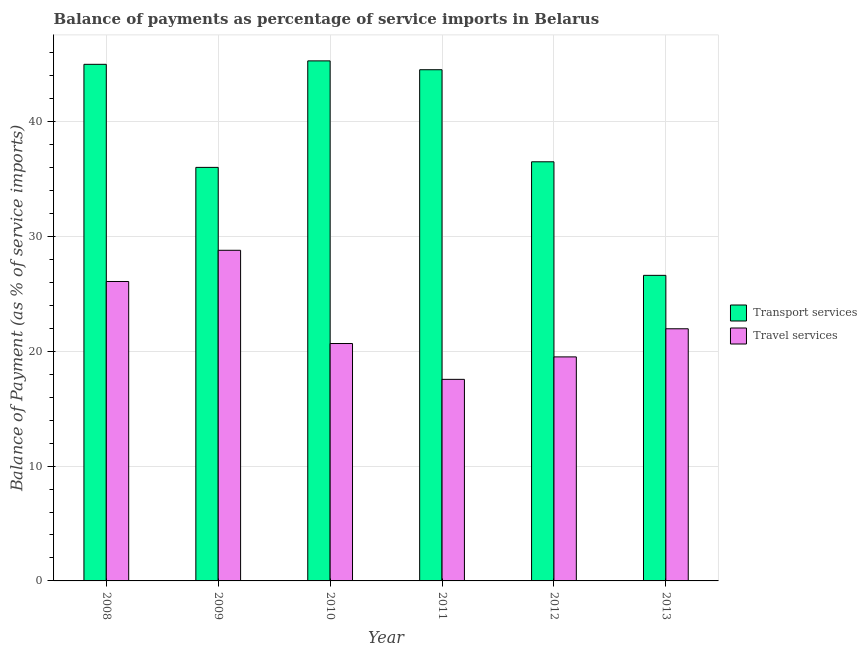How many different coloured bars are there?
Your answer should be compact. 2. Are the number of bars per tick equal to the number of legend labels?
Your answer should be very brief. Yes. Are the number of bars on each tick of the X-axis equal?
Your answer should be very brief. Yes. In how many cases, is the number of bars for a given year not equal to the number of legend labels?
Your answer should be compact. 0. What is the balance of payments of travel services in 2012?
Offer a terse response. 19.5. Across all years, what is the maximum balance of payments of transport services?
Your answer should be compact. 45.28. Across all years, what is the minimum balance of payments of travel services?
Provide a short and direct response. 17.55. What is the total balance of payments of transport services in the graph?
Provide a short and direct response. 233.87. What is the difference between the balance of payments of transport services in 2010 and that in 2012?
Provide a succinct answer. 8.79. What is the difference between the balance of payments of travel services in 2012 and the balance of payments of transport services in 2010?
Provide a short and direct response. -1.16. What is the average balance of payments of transport services per year?
Provide a succinct answer. 38.98. In the year 2008, what is the difference between the balance of payments of travel services and balance of payments of transport services?
Offer a very short reply. 0. In how many years, is the balance of payments of travel services greater than 44 %?
Provide a succinct answer. 0. What is the ratio of the balance of payments of transport services in 2008 to that in 2009?
Make the answer very short. 1.25. Is the balance of payments of travel services in 2010 less than that in 2012?
Provide a short and direct response. No. Is the difference between the balance of payments of transport services in 2009 and 2013 greater than the difference between the balance of payments of travel services in 2009 and 2013?
Keep it short and to the point. No. What is the difference between the highest and the second highest balance of payments of transport services?
Ensure brevity in your answer.  0.3. What is the difference between the highest and the lowest balance of payments of travel services?
Ensure brevity in your answer.  11.24. What does the 1st bar from the left in 2013 represents?
Provide a short and direct response. Transport services. What does the 2nd bar from the right in 2012 represents?
Offer a very short reply. Transport services. How many bars are there?
Provide a short and direct response. 12. Are all the bars in the graph horizontal?
Offer a very short reply. No. What is the difference between two consecutive major ticks on the Y-axis?
Offer a terse response. 10. Are the values on the major ticks of Y-axis written in scientific E-notation?
Provide a succinct answer. No. Where does the legend appear in the graph?
Make the answer very short. Center right. What is the title of the graph?
Provide a short and direct response. Balance of payments as percentage of service imports in Belarus. What is the label or title of the X-axis?
Provide a short and direct response. Year. What is the label or title of the Y-axis?
Your answer should be very brief. Balance of Payment (as % of service imports). What is the Balance of Payment (as % of service imports) in Transport services in 2008?
Give a very brief answer. 44.98. What is the Balance of Payment (as % of service imports) in Travel services in 2008?
Give a very brief answer. 26.07. What is the Balance of Payment (as % of service imports) in Transport services in 2009?
Give a very brief answer. 36.01. What is the Balance of Payment (as % of service imports) in Travel services in 2009?
Provide a succinct answer. 28.79. What is the Balance of Payment (as % of service imports) of Transport services in 2010?
Ensure brevity in your answer.  45.28. What is the Balance of Payment (as % of service imports) in Travel services in 2010?
Provide a short and direct response. 20.67. What is the Balance of Payment (as % of service imports) of Transport services in 2011?
Give a very brief answer. 44.51. What is the Balance of Payment (as % of service imports) of Travel services in 2011?
Your response must be concise. 17.55. What is the Balance of Payment (as % of service imports) in Transport services in 2012?
Offer a very short reply. 36.49. What is the Balance of Payment (as % of service imports) of Travel services in 2012?
Your answer should be very brief. 19.5. What is the Balance of Payment (as % of service imports) in Transport services in 2013?
Ensure brevity in your answer.  26.61. What is the Balance of Payment (as % of service imports) in Travel services in 2013?
Give a very brief answer. 21.95. Across all years, what is the maximum Balance of Payment (as % of service imports) of Transport services?
Give a very brief answer. 45.28. Across all years, what is the maximum Balance of Payment (as % of service imports) of Travel services?
Provide a succinct answer. 28.79. Across all years, what is the minimum Balance of Payment (as % of service imports) in Transport services?
Offer a terse response. 26.61. Across all years, what is the minimum Balance of Payment (as % of service imports) in Travel services?
Your response must be concise. 17.55. What is the total Balance of Payment (as % of service imports) of Transport services in the graph?
Offer a terse response. 233.87. What is the total Balance of Payment (as % of service imports) of Travel services in the graph?
Offer a terse response. 134.53. What is the difference between the Balance of Payment (as % of service imports) of Transport services in 2008 and that in 2009?
Keep it short and to the point. 8.97. What is the difference between the Balance of Payment (as % of service imports) of Travel services in 2008 and that in 2009?
Ensure brevity in your answer.  -2.72. What is the difference between the Balance of Payment (as % of service imports) of Transport services in 2008 and that in 2010?
Ensure brevity in your answer.  -0.3. What is the difference between the Balance of Payment (as % of service imports) of Travel services in 2008 and that in 2010?
Your response must be concise. 5.4. What is the difference between the Balance of Payment (as % of service imports) of Transport services in 2008 and that in 2011?
Keep it short and to the point. 0.47. What is the difference between the Balance of Payment (as % of service imports) in Travel services in 2008 and that in 2011?
Give a very brief answer. 8.52. What is the difference between the Balance of Payment (as % of service imports) of Transport services in 2008 and that in 2012?
Make the answer very short. 8.49. What is the difference between the Balance of Payment (as % of service imports) of Travel services in 2008 and that in 2012?
Offer a terse response. 6.57. What is the difference between the Balance of Payment (as % of service imports) in Transport services in 2008 and that in 2013?
Your answer should be very brief. 18.37. What is the difference between the Balance of Payment (as % of service imports) of Travel services in 2008 and that in 2013?
Your answer should be very brief. 4.12. What is the difference between the Balance of Payment (as % of service imports) in Transport services in 2009 and that in 2010?
Provide a succinct answer. -9.27. What is the difference between the Balance of Payment (as % of service imports) in Travel services in 2009 and that in 2010?
Offer a very short reply. 8.12. What is the difference between the Balance of Payment (as % of service imports) of Transport services in 2009 and that in 2011?
Your response must be concise. -8.5. What is the difference between the Balance of Payment (as % of service imports) in Travel services in 2009 and that in 2011?
Your response must be concise. 11.24. What is the difference between the Balance of Payment (as % of service imports) in Transport services in 2009 and that in 2012?
Offer a terse response. -0.49. What is the difference between the Balance of Payment (as % of service imports) of Travel services in 2009 and that in 2012?
Make the answer very short. 9.28. What is the difference between the Balance of Payment (as % of service imports) of Transport services in 2009 and that in 2013?
Make the answer very short. 9.4. What is the difference between the Balance of Payment (as % of service imports) of Travel services in 2009 and that in 2013?
Offer a very short reply. 6.83. What is the difference between the Balance of Payment (as % of service imports) of Transport services in 2010 and that in 2011?
Your response must be concise. 0.77. What is the difference between the Balance of Payment (as % of service imports) of Travel services in 2010 and that in 2011?
Keep it short and to the point. 3.12. What is the difference between the Balance of Payment (as % of service imports) in Transport services in 2010 and that in 2012?
Offer a very short reply. 8.79. What is the difference between the Balance of Payment (as % of service imports) of Travel services in 2010 and that in 2012?
Offer a very short reply. 1.16. What is the difference between the Balance of Payment (as % of service imports) in Transport services in 2010 and that in 2013?
Keep it short and to the point. 18.67. What is the difference between the Balance of Payment (as % of service imports) of Travel services in 2010 and that in 2013?
Your answer should be compact. -1.28. What is the difference between the Balance of Payment (as % of service imports) in Transport services in 2011 and that in 2012?
Offer a terse response. 8.02. What is the difference between the Balance of Payment (as % of service imports) of Travel services in 2011 and that in 2012?
Make the answer very short. -1.96. What is the difference between the Balance of Payment (as % of service imports) in Transport services in 2011 and that in 2013?
Ensure brevity in your answer.  17.9. What is the difference between the Balance of Payment (as % of service imports) in Travel services in 2011 and that in 2013?
Offer a very short reply. -4.4. What is the difference between the Balance of Payment (as % of service imports) in Transport services in 2012 and that in 2013?
Offer a very short reply. 9.89. What is the difference between the Balance of Payment (as % of service imports) of Travel services in 2012 and that in 2013?
Offer a terse response. -2.45. What is the difference between the Balance of Payment (as % of service imports) in Transport services in 2008 and the Balance of Payment (as % of service imports) in Travel services in 2009?
Offer a terse response. 16.19. What is the difference between the Balance of Payment (as % of service imports) in Transport services in 2008 and the Balance of Payment (as % of service imports) in Travel services in 2010?
Ensure brevity in your answer.  24.31. What is the difference between the Balance of Payment (as % of service imports) of Transport services in 2008 and the Balance of Payment (as % of service imports) of Travel services in 2011?
Provide a succinct answer. 27.43. What is the difference between the Balance of Payment (as % of service imports) of Transport services in 2008 and the Balance of Payment (as % of service imports) of Travel services in 2012?
Your answer should be compact. 25.47. What is the difference between the Balance of Payment (as % of service imports) of Transport services in 2008 and the Balance of Payment (as % of service imports) of Travel services in 2013?
Give a very brief answer. 23.03. What is the difference between the Balance of Payment (as % of service imports) of Transport services in 2009 and the Balance of Payment (as % of service imports) of Travel services in 2010?
Your answer should be very brief. 15.34. What is the difference between the Balance of Payment (as % of service imports) of Transport services in 2009 and the Balance of Payment (as % of service imports) of Travel services in 2011?
Make the answer very short. 18.46. What is the difference between the Balance of Payment (as % of service imports) in Transport services in 2009 and the Balance of Payment (as % of service imports) in Travel services in 2012?
Offer a very short reply. 16.5. What is the difference between the Balance of Payment (as % of service imports) of Transport services in 2009 and the Balance of Payment (as % of service imports) of Travel services in 2013?
Your answer should be compact. 14.05. What is the difference between the Balance of Payment (as % of service imports) of Transport services in 2010 and the Balance of Payment (as % of service imports) of Travel services in 2011?
Make the answer very short. 27.73. What is the difference between the Balance of Payment (as % of service imports) in Transport services in 2010 and the Balance of Payment (as % of service imports) in Travel services in 2012?
Provide a succinct answer. 25.77. What is the difference between the Balance of Payment (as % of service imports) in Transport services in 2010 and the Balance of Payment (as % of service imports) in Travel services in 2013?
Provide a short and direct response. 23.32. What is the difference between the Balance of Payment (as % of service imports) in Transport services in 2011 and the Balance of Payment (as % of service imports) in Travel services in 2012?
Offer a terse response. 25. What is the difference between the Balance of Payment (as % of service imports) in Transport services in 2011 and the Balance of Payment (as % of service imports) in Travel services in 2013?
Provide a succinct answer. 22.55. What is the difference between the Balance of Payment (as % of service imports) of Transport services in 2012 and the Balance of Payment (as % of service imports) of Travel services in 2013?
Your answer should be very brief. 14.54. What is the average Balance of Payment (as % of service imports) in Transport services per year?
Keep it short and to the point. 38.98. What is the average Balance of Payment (as % of service imports) in Travel services per year?
Offer a terse response. 22.42. In the year 2008, what is the difference between the Balance of Payment (as % of service imports) of Transport services and Balance of Payment (as % of service imports) of Travel services?
Your response must be concise. 18.91. In the year 2009, what is the difference between the Balance of Payment (as % of service imports) in Transport services and Balance of Payment (as % of service imports) in Travel services?
Your answer should be very brief. 7.22. In the year 2010, what is the difference between the Balance of Payment (as % of service imports) of Transport services and Balance of Payment (as % of service imports) of Travel services?
Make the answer very short. 24.61. In the year 2011, what is the difference between the Balance of Payment (as % of service imports) of Transport services and Balance of Payment (as % of service imports) of Travel services?
Offer a terse response. 26.96. In the year 2012, what is the difference between the Balance of Payment (as % of service imports) in Transport services and Balance of Payment (as % of service imports) in Travel services?
Provide a short and direct response. 16.99. In the year 2013, what is the difference between the Balance of Payment (as % of service imports) in Transport services and Balance of Payment (as % of service imports) in Travel services?
Make the answer very short. 4.65. What is the ratio of the Balance of Payment (as % of service imports) in Transport services in 2008 to that in 2009?
Offer a terse response. 1.25. What is the ratio of the Balance of Payment (as % of service imports) in Travel services in 2008 to that in 2009?
Provide a succinct answer. 0.91. What is the ratio of the Balance of Payment (as % of service imports) in Travel services in 2008 to that in 2010?
Keep it short and to the point. 1.26. What is the ratio of the Balance of Payment (as % of service imports) of Transport services in 2008 to that in 2011?
Your response must be concise. 1.01. What is the ratio of the Balance of Payment (as % of service imports) in Travel services in 2008 to that in 2011?
Provide a short and direct response. 1.49. What is the ratio of the Balance of Payment (as % of service imports) in Transport services in 2008 to that in 2012?
Give a very brief answer. 1.23. What is the ratio of the Balance of Payment (as % of service imports) in Travel services in 2008 to that in 2012?
Provide a short and direct response. 1.34. What is the ratio of the Balance of Payment (as % of service imports) in Transport services in 2008 to that in 2013?
Provide a short and direct response. 1.69. What is the ratio of the Balance of Payment (as % of service imports) in Travel services in 2008 to that in 2013?
Keep it short and to the point. 1.19. What is the ratio of the Balance of Payment (as % of service imports) of Transport services in 2009 to that in 2010?
Ensure brevity in your answer.  0.8. What is the ratio of the Balance of Payment (as % of service imports) of Travel services in 2009 to that in 2010?
Your response must be concise. 1.39. What is the ratio of the Balance of Payment (as % of service imports) of Transport services in 2009 to that in 2011?
Your response must be concise. 0.81. What is the ratio of the Balance of Payment (as % of service imports) in Travel services in 2009 to that in 2011?
Offer a terse response. 1.64. What is the ratio of the Balance of Payment (as % of service imports) of Transport services in 2009 to that in 2012?
Offer a terse response. 0.99. What is the ratio of the Balance of Payment (as % of service imports) of Travel services in 2009 to that in 2012?
Your answer should be compact. 1.48. What is the ratio of the Balance of Payment (as % of service imports) in Transport services in 2009 to that in 2013?
Offer a very short reply. 1.35. What is the ratio of the Balance of Payment (as % of service imports) in Travel services in 2009 to that in 2013?
Provide a short and direct response. 1.31. What is the ratio of the Balance of Payment (as % of service imports) in Transport services in 2010 to that in 2011?
Provide a short and direct response. 1.02. What is the ratio of the Balance of Payment (as % of service imports) in Travel services in 2010 to that in 2011?
Offer a very short reply. 1.18. What is the ratio of the Balance of Payment (as % of service imports) of Transport services in 2010 to that in 2012?
Offer a very short reply. 1.24. What is the ratio of the Balance of Payment (as % of service imports) in Travel services in 2010 to that in 2012?
Ensure brevity in your answer.  1.06. What is the ratio of the Balance of Payment (as % of service imports) in Transport services in 2010 to that in 2013?
Your answer should be compact. 1.7. What is the ratio of the Balance of Payment (as % of service imports) of Travel services in 2010 to that in 2013?
Your answer should be compact. 0.94. What is the ratio of the Balance of Payment (as % of service imports) in Transport services in 2011 to that in 2012?
Offer a very short reply. 1.22. What is the ratio of the Balance of Payment (as % of service imports) in Travel services in 2011 to that in 2012?
Give a very brief answer. 0.9. What is the ratio of the Balance of Payment (as % of service imports) of Transport services in 2011 to that in 2013?
Make the answer very short. 1.67. What is the ratio of the Balance of Payment (as % of service imports) of Travel services in 2011 to that in 2013?
Provide a succinct answer. 0.8. What is the ratio of the Balance of Payment (as % of service imports) in Transport services in 2012 to that in 2013?
Provide a succinct answer. 1.37. What is the ratio of the Balance of Payment (as % of service imports) in Travel services in 2012 to that in 2013?
Ensure brevity in your answer.  0.89. What is the difference between the highest and the second highest Balance of Payment (as % of service imports) of Transport services?
Your answer should be compact. 0.3. What is the difference between the highest and the second highest Balance of Payment (as % of service imports) in Travel services?
Your answer should be compact. 2.72. What is the difference between the highest and the lowest Balance of Payment (as % of service imports) of Transport services?
Offer a very short reply. 18.67. What is the difference between the highest and the lowest Balance of Payment (as % of service imports) of Travel services?
Give a very brief answer. 11.24. 